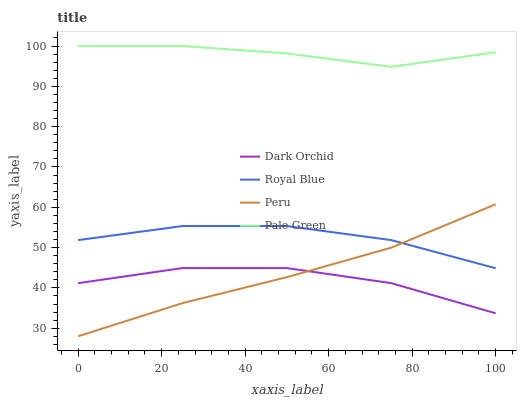Does Dark Orchid have the minimum area under the curve?
Answer yes or no. Yes. Does Pale Green have the maximum area under the curve?
Answer yes or no. Yes. Does Peru have the minimum area under the curve?
Answer yes or no. No. Does Peru have the maximum area under the curve?
Answer yes or no. No. Is Peru the smoothest?
Answer yes or no. Yes. Is Dark Orchid the roughest?
Answer yes or no. Yes. Is Pale Green the smoothest?
Answer yes or no. No. Is Pale Green the roughest?
Answer yes or no. No. Does Peru have the lowest value?
Answer yes or no. Yes. Does Pale Green have the lowest value?
Answer yes or no. No. Does Pale Green have the highest value?
Answer yes or no. Yes. Does Peru have the highest value?
Answer yes or no. No. Is Dark Orchid less than Royal Blue?
Answer yes or no. Yes. Is Pale Green greater than Peru?
Answer yes or no. Yes. Does Royal Blue intersect Peru?
Answer yes or no. Yes. Is Royal Blue less than Peru?
Answer yes or no. No. Is Royal Blue greater than Peru?
Answer yes or no. No. Does Dark Orchid intersect Royal Blue?
Answer yes or no. No. 